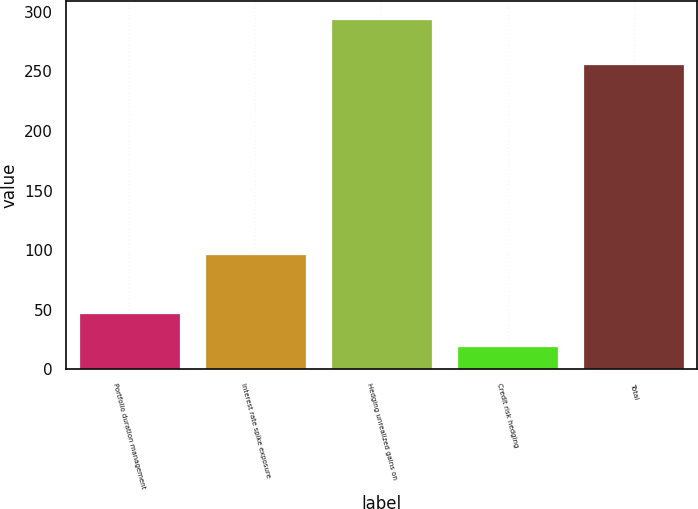Convert chart. <chart><loc_0><loc_0><loc_500><loc_500><bar_chart><fcel>Portfolio duration management<fcel>Interest rate spike exposure<fcel>Hedging unrealized gains on<fcel>Credit risk hedging<fcel>Total<nl><fcel>47.4<fcel>97<fcel>294<fcel>20<fcel>256<nl></chart> 